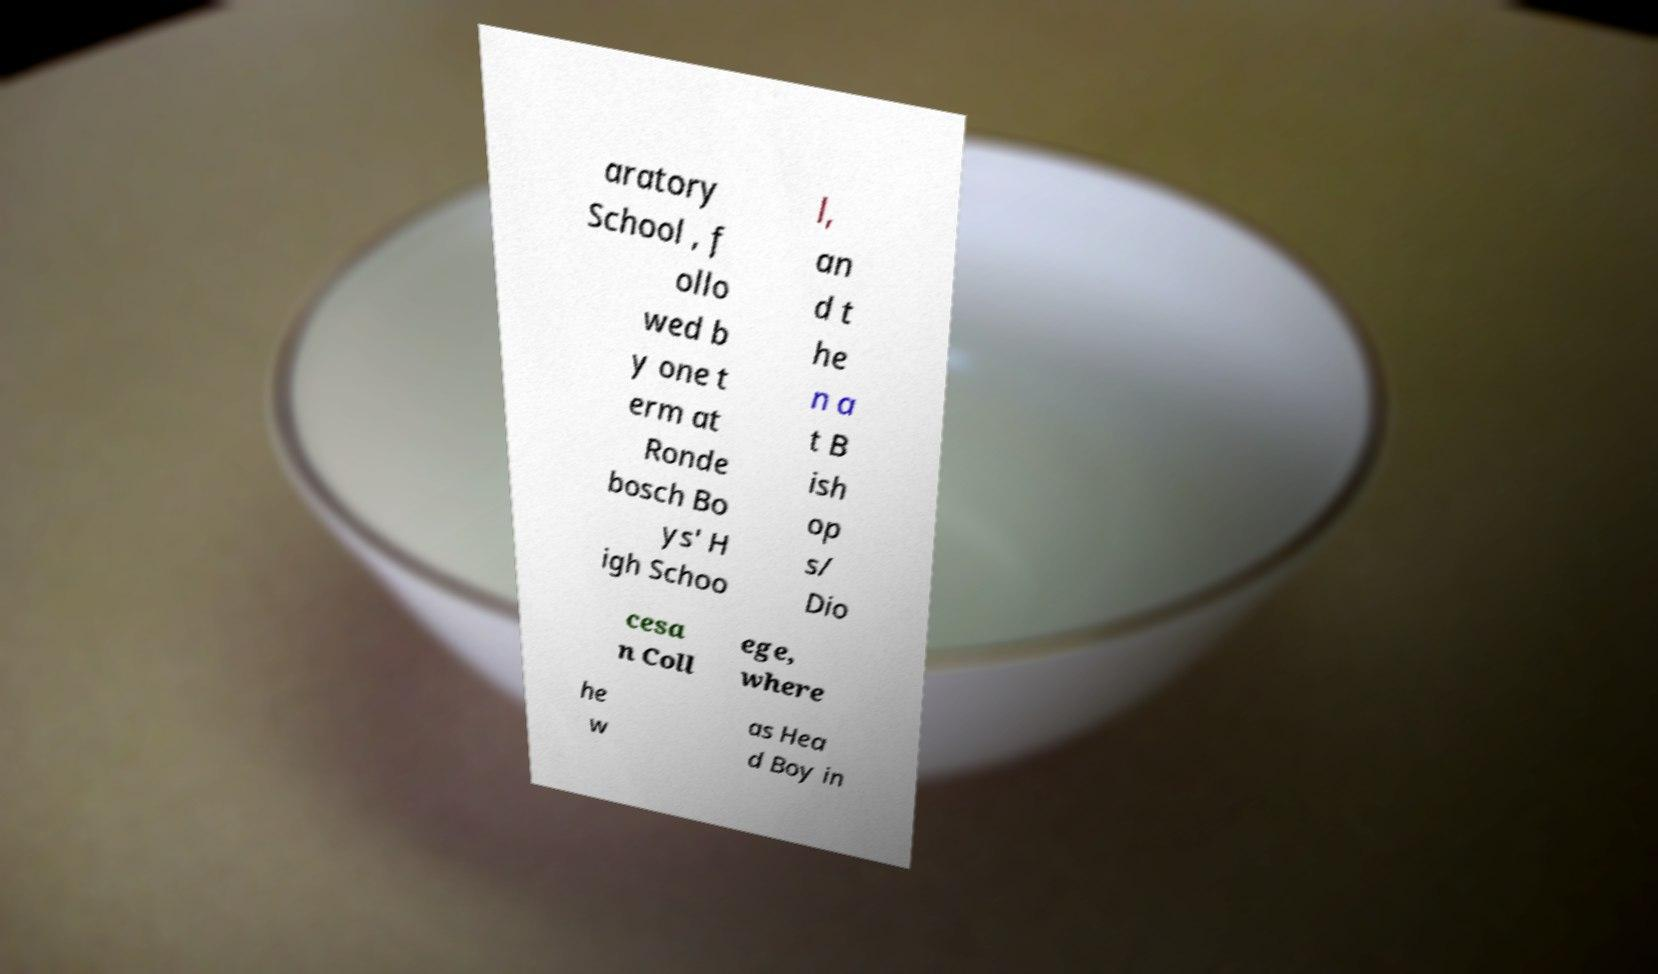Please read and relay the text visible in this image. What does it say? aratory School , f ollo wed b y one t erm at Ronde bosch Bo ys' H igh Schoo l, an d t he n a t B ish op s/ Dio cesa n Coll ege, where he w as Hea d Boy in 